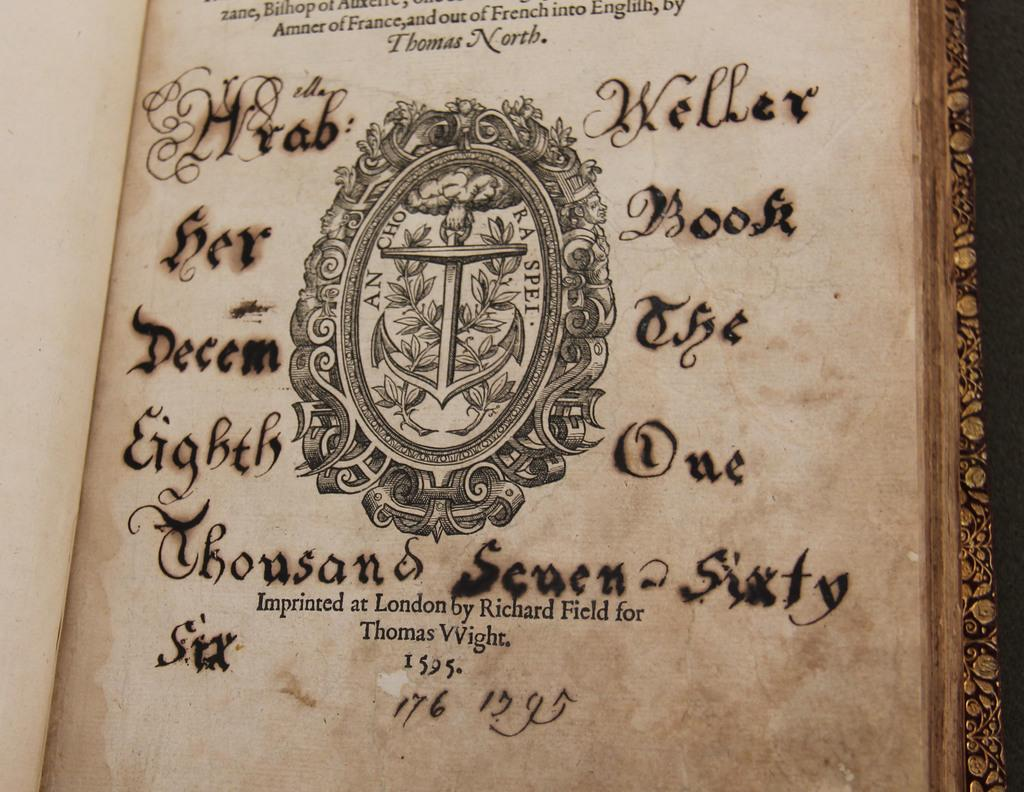<image>
Summarize the visual content of the image. A book that was imprinted in London is open to the title page. 